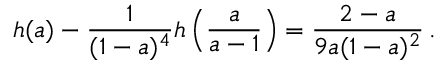Convert formula to latex. <formula><loc_0><loc_0><loc_500><loc_500>h ( a ) - { \frac { 1 } { ( 1 - a ) ^ { 4 } } } h \left ( { \frac { a } { a - 1 } } \right ) = { \frac { 2 - a } { 9 a ( 1 - a ) ^ { 2 } } } \, .</formula> 